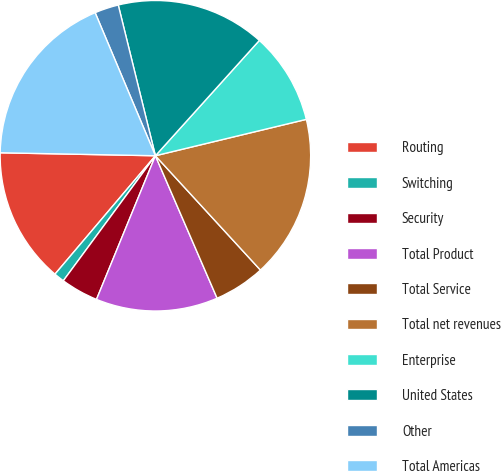Convert chart to OTSL. <chart><loc_0><loc_0><loc_500><loc_500><pie_chart><fcel>Routing<fcel>Switching<fcel>Security<fcel>Total Product<fcel>Total Service<fcel>Total net revenues<fcel>Enterprise<fcel>United States<fcel>Other<fcel>Total Americas<nl><fcel>14.11%<fcel>1.09%<fcel>3.91%<fcel>12.7%<fcel>5.32%<fcel>16.94%<fcel>9.56%<fcel>15.52%<fcel>2.5%<fcel>18.35%<nl></chart> 